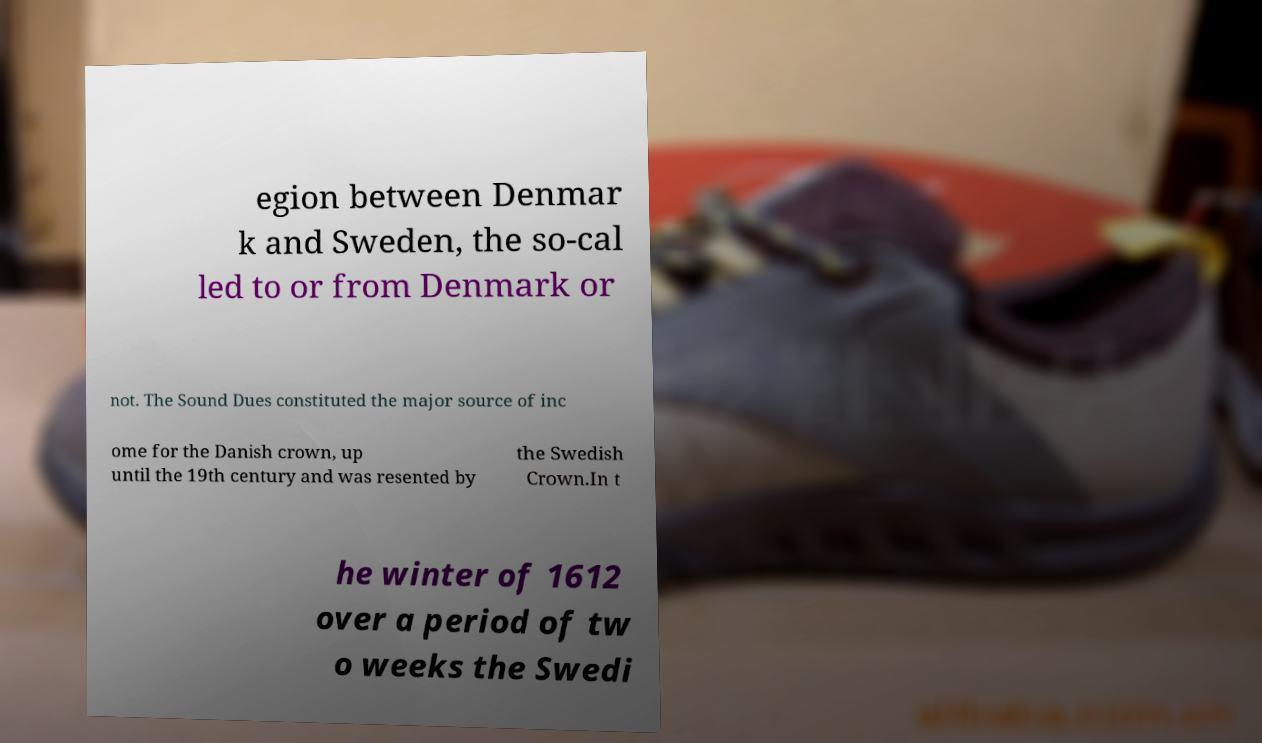I need the written content from this picture converted into text. Can you do that? egion between Denmar k and Sweden, the so-cal led to or from Denmark or not. The Sound Dues constituted the major source of inc ome for the Danish crown, up until the 19th century and was resented by the Swedish Crown.In t he winter of 1612 over a period of tw o weeks the Swedi 